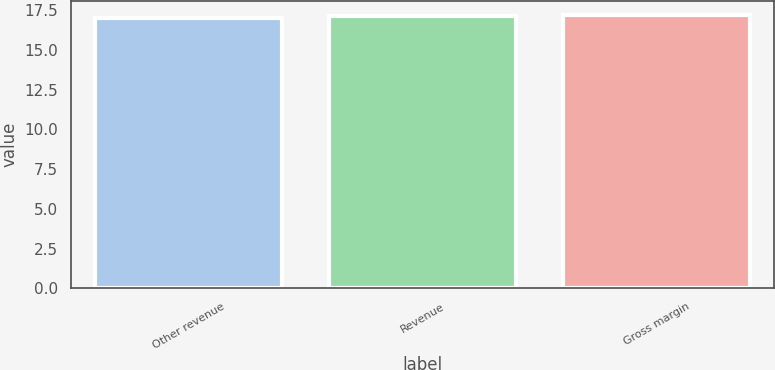<chart> <loc_0><loc_0><loc_500><loc_500><bar_chart><fcel>Other revenue<fcel>Revenue<fcel>Gross margin<nl><fcel>17<fcel>17.1<fcel>17.2<nl></chart> 